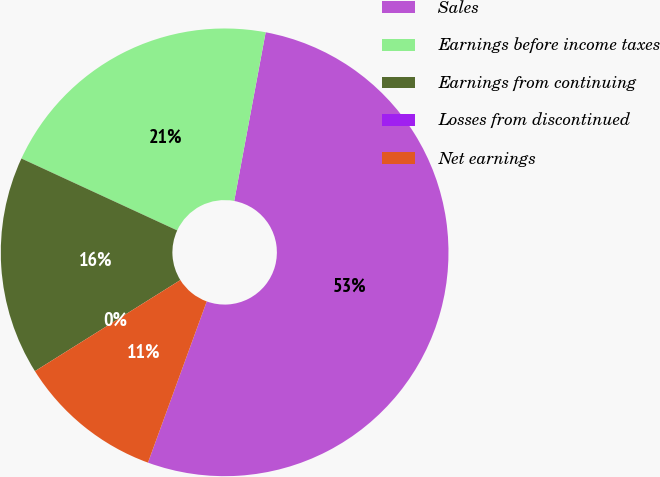Convert chart. <chart><loc_0><loc_0><loc_500><loc_500><pie_chart><fcel>Sales<fcel>Earnings before income taxes<fcel>Earnings from continuing<fcel>Losses from discontinued<fcel>Net earnings<nl><fcel>52.63%<fcel>21.05%<fcel>15.79%<fcel>0.0%<fcel>10.53%<nl></chart> 